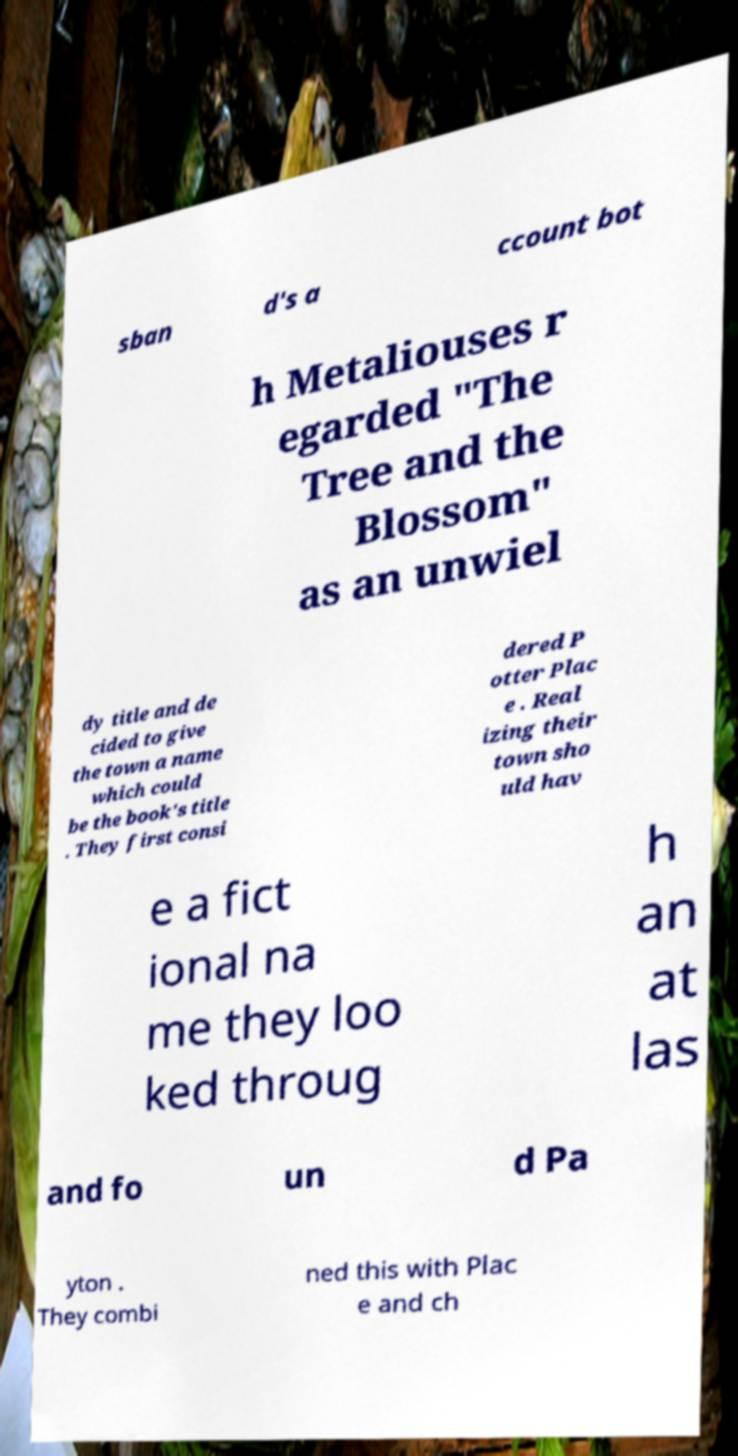Could you assist in decoding the text presented in this image and type it out clearly? sban d's a ccount bot h Metaliouses r egarded "The Tree and the Blossom" as an unwiel dy title and de cided to give the town a name which could be the book's title . They first consi dered P otter Plac e . Real izing their town sho uld hav e a fict ional na me they loo ked throug h an at las and fo un d Pa yton . They combi ned this with Plac e and ch 